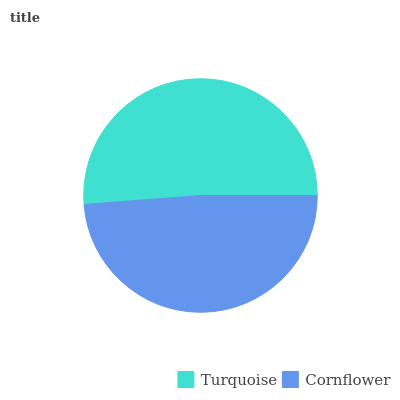Is Cornflower the minimum?
Answer yes or no. Yes. Is Turquoise the maximum?
Answer yes or no. Yes. Is Cornflower the maximum?
Answer yes or no. No. Is Turquoise greater than Cornflower?
Answer yes or no. Yes. Is Cornflower less than Turquoise?
Answer yes or no. Yes. Is Cornflower greater than Turquoise?
Answer yes or no. No. Is Turquoise less than Cornflower?
Answer yes or no. No. Is Turquoise the high median?
Answer yes or no. Yes. Is Cornflower the low median?
Answer yes or no. Yes. Is Cornflower the high median?
Answer yes or no. No. Is Turquoise the low median?
Answer yes or no. No. 